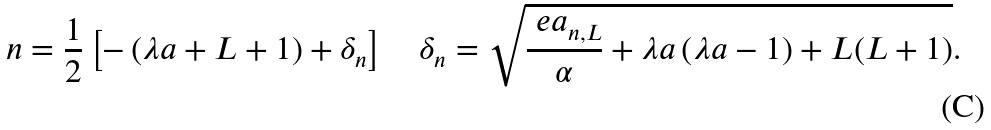<formula> <loc_0><loc_0><loc_500><loc_500>n = \frac { 1 } { 2 } \left [ - \left ( \lambda a + L + 1 \right ) + \delta _ { n } \right ] \quad \delta _ { n } = \sqrt { \frac { \ e a _ { n , L } } { \alpha } + \lambda a \left ( \lambda a - 1 \right ) + L ( L + 1 ) } .</formula> 